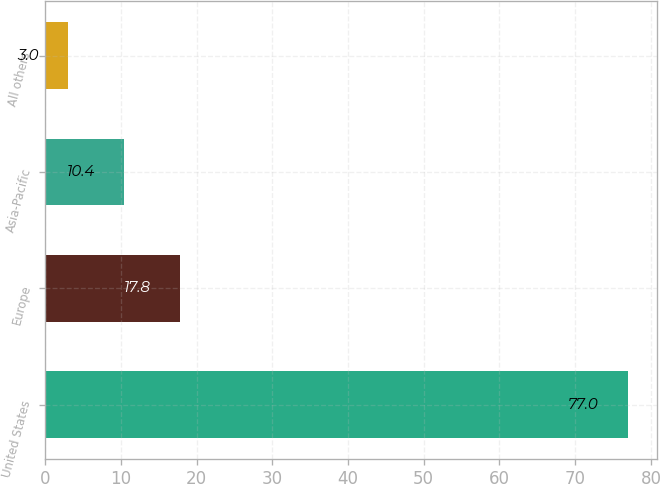Convert chart. <chart><loc_0><loc_0><loc_500><loc_500><bar_chart><fcel>United States<fcel>Europe<fcel>Asia-Pacific<fcel>All others<nl><fcel>77<fcel>17.8<fcel>10.4<fcel>3<nl></chart> 